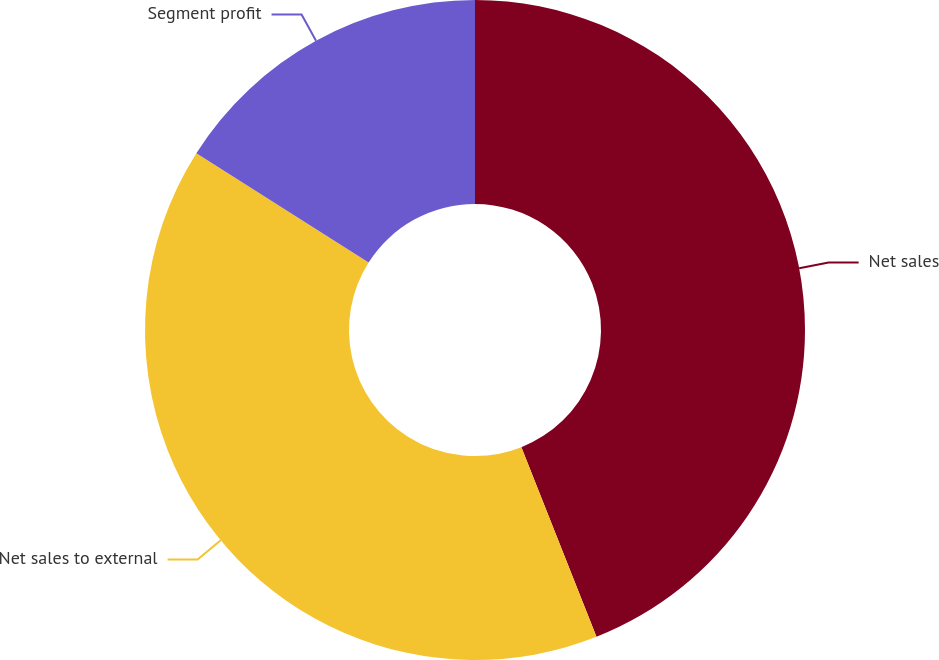Convert chart to OTSL. <chart><loc_0><loc_0><loc_500><loc_500><pie_chart><fcel>Net sales<fcel>Net sales to external<fcel>Segment profit<nl><fcel>44.0%<fcel>40.0%<fcel>16.0%<nl></chart> 